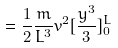<formula> <loc_0><loc_0><loc_500><loc_500>= \frac { 1 } { 2 } \frac { m } { L ^ { 3 } } v ^ { 2 } [ \frac { y ^ { 3 } } { 3 } ] _ { 0 } ^ { L }</formula> 